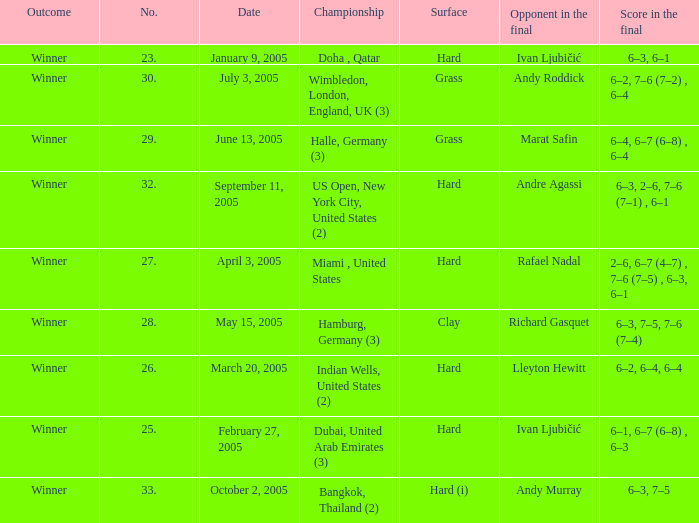Andy Roddick is the opponent in the final on what surface? Grass. 